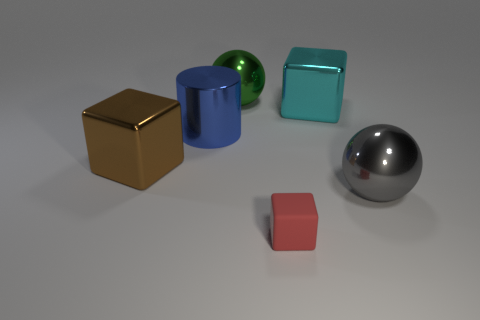How many brown things are either matte blocks or big blocks?
Offer a very short reply. 1. What number of cyan metallic cubes have the same size as the green metallic sphere?
Provide a succinct answer. 1. Does the large cube that is behind the big blue metallic cylinder have the same material as the tiny block?
Your answer should be compact. No. There is a ball that is in front of the large brown metal object; are there any large brown shiny cubes that are to the right of it?
Your answer should be very brief. No. There is another big thing that is the same shape as the green shiny object; what is its material?
Your answer should be very brief. Metal. Are there more gray metal objects that are behind the gray sphere than metallic cubes in front of the metallic cylinder?
Keep it short and to the point. No. What shape is the large blue object that is made of the same material as the gray object?
Your answer should be very brief. Cylinder. Is the number of big green metal objects left of the green metal object greater than the number of spheres?
Your answer should be very brief. No. What number of tiny cubes are the same color as the small thing?
Make the answer very short. 0. How many other objects are the same color as the rubber block?
Ensure brevity in your answer.  0. 